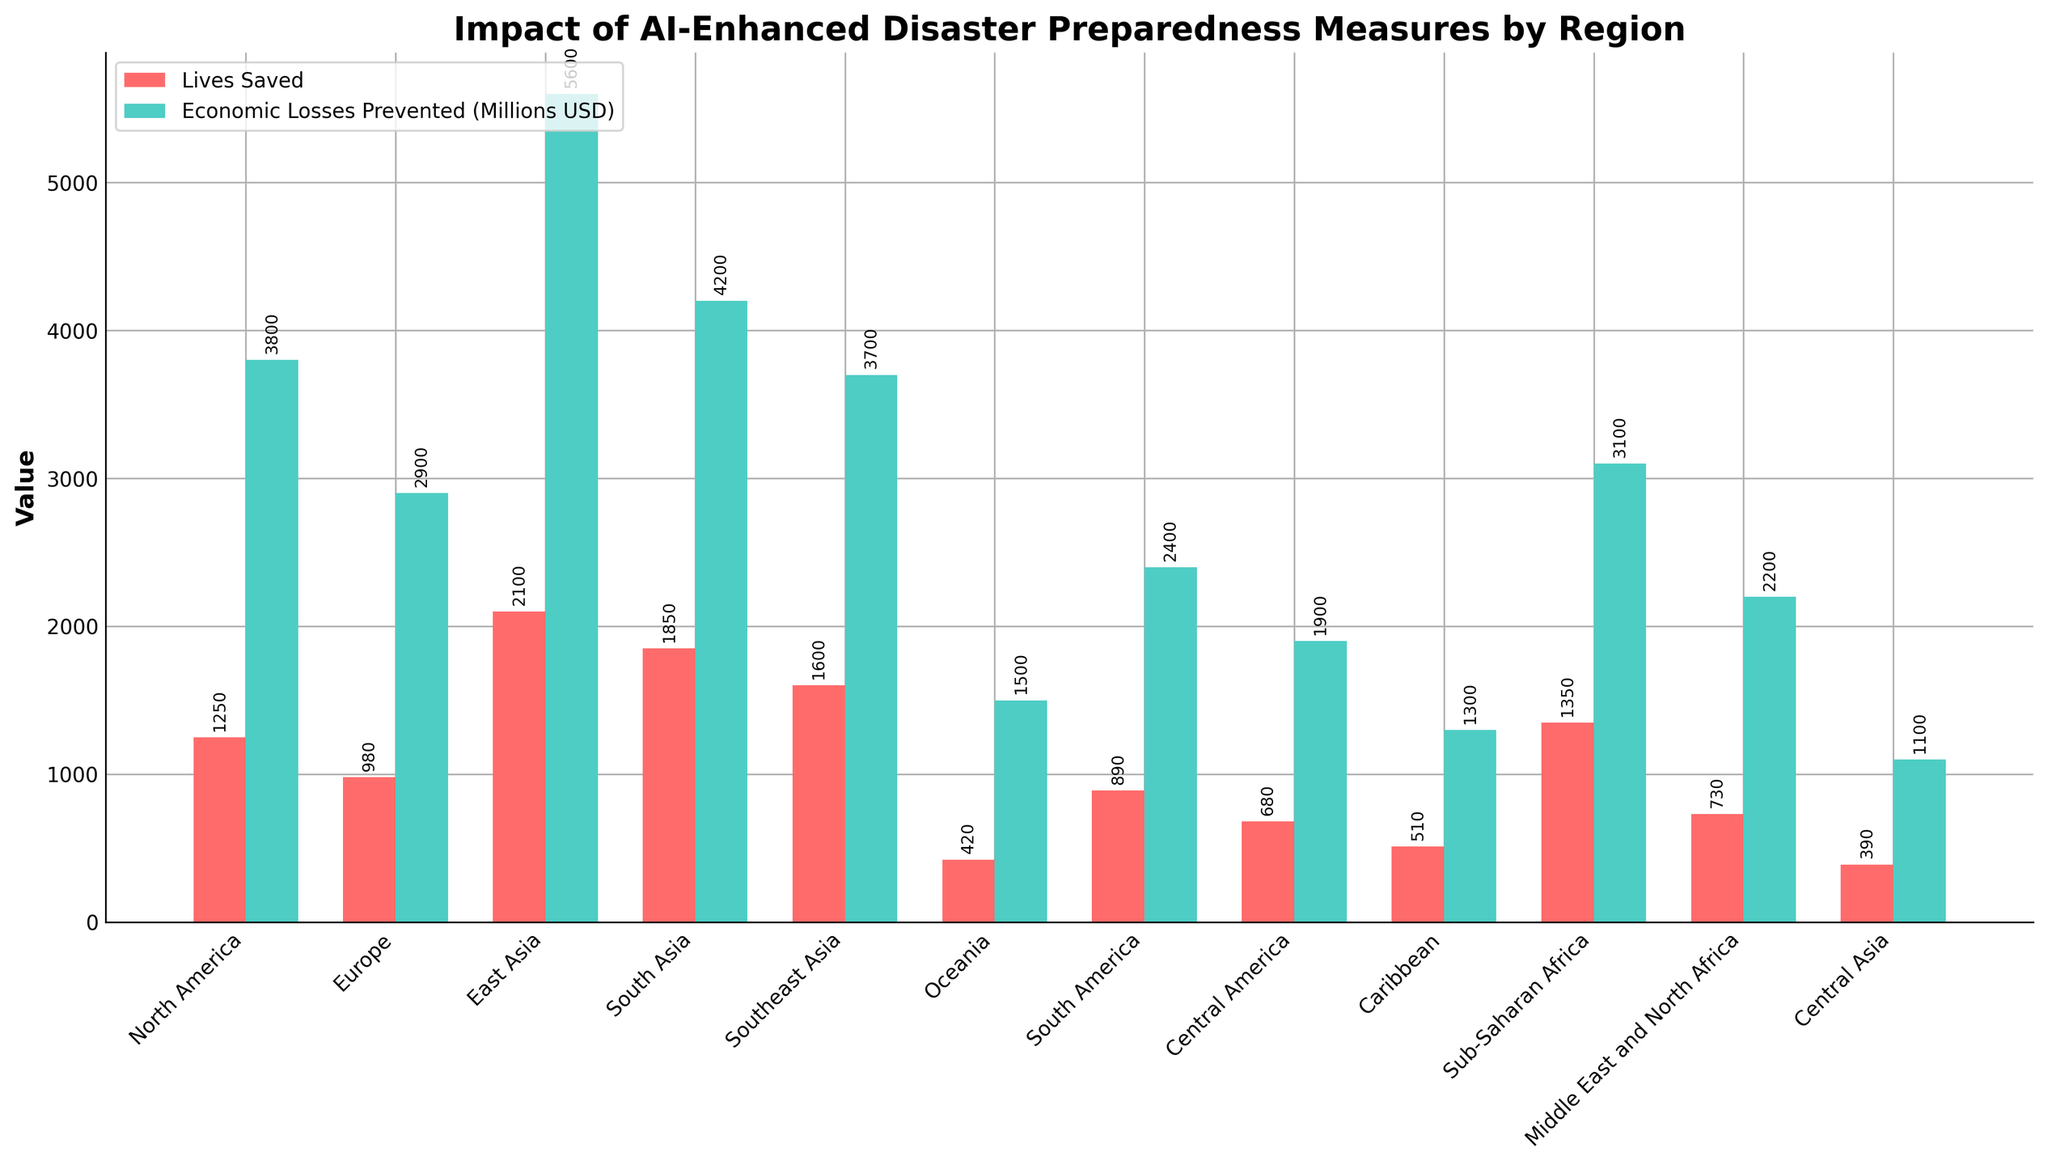Which region has the highest number of lives saved? The bar representing East Asia is the tallest among the lives saved bars, indicating the highest number of lives saved.
Answer: East Asia Which region has the lowest economic losses prevented? The bar for Central Asia is the shortest among the economic losses prevented bars, indicating the lowest economic losses prevented.
Answer: Central Asia What is the total number of lives saved in South Asia and Southeast Asia? Summing the values from the bars for South Asia and Southeast Asia gives 1850 + 1600.
Answer: 3450 Which has more economic losses prevented, Europe or Sub-Saharan Africa? Comparing the heights of the bars for economic losses prevented, Europe has 2900 and Sub-Saharan Africa has 3100, indicating Sub-Saharan Africa has more.
Answer: Sub-Saharan Africa How does the number of lives saved in North America compare to the economic losses prevented there? The bar for lives saved in North America is at 1250, while the bar for economic losses prevented is at 3800, showing that economic losses prevented is significantly higher.
Answer: Economic losses prevented is higher What percentage of the total number of lives saved is attributed to East Asia? Total number of lives saved across all regions is 14650. East Asia saved 2100 lives. (2100 / 14650) * 100 ≈ 14.34%.
Answer: ~14.34% Which region saved more lives, Oceania or the Caribbean? Comparing the heights of the lives saved bars, Oceania saved 420 lives and the Caribbean saved 510 lives, indicating the Caribbean saved more lives.
Answer: Caribbean How much more in economic losses was prevented in East Asia than in South America? Subtracting the economic losses prevented in South America from those in East Asia: 5600 - 2400.
Answer: 3200 What is the difference between the number of lives saved and economic losses prevented in Sub-Saharan Africa? The number of lives saved is 1350 and economic losses prevented is 3100. Subtracting these gives 3100 - 1350.
Answer: 1750 